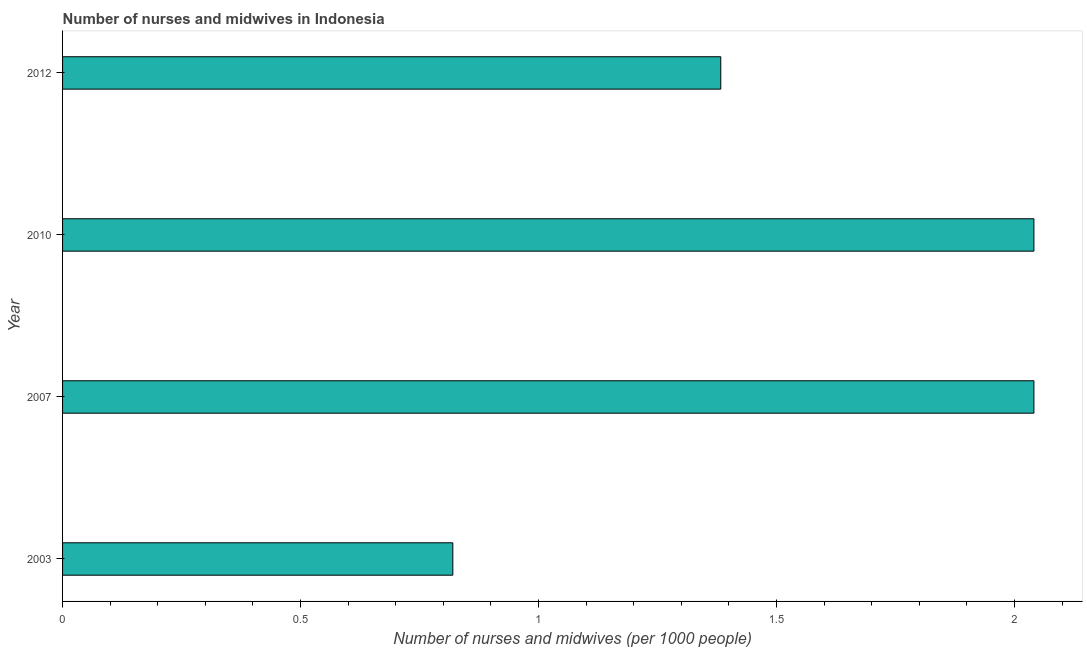Does the graph contain any zero values?
Your answer should be compact. No. Does the graph contain grids?
Offer a very short reply. No. What is the title of the graph?
Offer a terse response. Number of nurses and midwives in Indonesia. What is the label or title of the X-axis?
Provide a succinct answer. Number of nurses and midwives (per 1000 people). What is the number of nurses and midwives in 2007?
Make the answer very short. 2.04. Across all years, what is the maximum number of nurses and midwives?
Ensure brevity in your answer.  2.04. Across all years, what is the minimum number of nurses and midwives?
Give a very brief answer. 0.82. In which year was the number of nurses and midwives maximum?
Offer a very short reply. 2007. What is the sum of the number of nurses and midwives?
Keep it short and to the point. 6.28. What is the difference between the number of nurses and midwives in 2007 and 2012?
Keep it short and to the point. 0.66. What is the average number of nurses and midwives per year?
Ensure brevity in your answer.  1.57. What is the median number of nurses and midwives?
Provide a succinct answer. 1.71. In how many years, is the number of nurses and midwives greater than 1.6 ?
Offer a very short reply. 2. Do a majority of the years between 2010 and 2007 (inclusive) have number of nurses and midwives greater than 0.3 ?
Offer a very short reply. No. What is the ratio of the number of nurses and midwives in 2003 to that in 2007?
Make the answer very short. 0.4. Is the number of nurses and midwives in 2007 less than that in 2010?
Your answer should be compact. No. Is the difference between the number of nurses and midwives in 2003 and 2007 greater than the difference between any two years?
Provide a short and direct response. Yes. Is the sum of the number of nurses and midwives in 2003 and 2012 greater than the maximum number of nurses and midwives across all years?
Provide a succinct answer. Yes. What is the difference between the highest and the lowest number of nurses and midwives?
Your answer should be compact. 1.22. In how many years, is the number of nurses and midwives greater than the average number of nurses and midwives taken over all years?
Make the answer very short. 2. How many bars are there?
Give a very brief answer. 4. How many years are there in the graph?
Your answer should be very brief. 4. What is the difference between two consecutive major ticks on the X-axis?
Your answer should be very brief. 0.5. What is the Number of nurses and midwives (per 1000 people) of 2003?
Keep it short and to the point. 0.82. What is the Number of nurses and midwives (per 1000 people) of 2007?
Keep it short and to the point. 2.04. What is the Number of nurses and midwives (per 1000 people) in 2010?
Provide a succinct answer. 2.04. What is the Number of nurses and midwives (per 1000 people) in 2012?
Your response must be concise. 1.38. What is the difference between the Number of nurses and midwives (per 1000 people) in 2003 and 2007?
Ensure brevity in your answer.  -1.22. What is the difference between the Number of nurses and midwives (per 1000 people) in 2003 and 2010?
Provide a succinct answer. -1.22. What is the difference between the Number of nurses and midwives (per 1000 people) in 2003 and 2012?
Offer a very short reply. -0.56. What is the difference between the Number of nurses and midwives (per 1000 people) in 2007 and 2012?
Your response must be concise. 0.66. What is the difference between the Number of nurses and midwives (per 1000 people) in 2010 and 2012?
Make the answer very short. 0.66. What is the ratio of the Number of nurses and midwives (per 1000 people) in 2003 to that in 2007?
Your answer should be compact. 0.4. What is the ratio of the Number of nurses and midwives (per 1000 people) in 2003 to that in 2010?
Your response must be concise. 0.4. What is the ratio of the Number of nurses and midwives (per 1000 people) in 2003 to that in 2012?
Offer a very short reply. 0.59. What is the ratio of the Number of nurses and midwives (per 1000 people) in 2007 to that in 2010?
Provide a succinct answer. 1. What is the ratio of the Number of nurses and midwives (per 1000 people) in 2007 to that in 2012?
Make the answer very short. 1.48. What is the ratio of the Number of nurses and midwives (per 1000 people) in 2010 to that in 2012?
Make the answer very short. 1.48. 